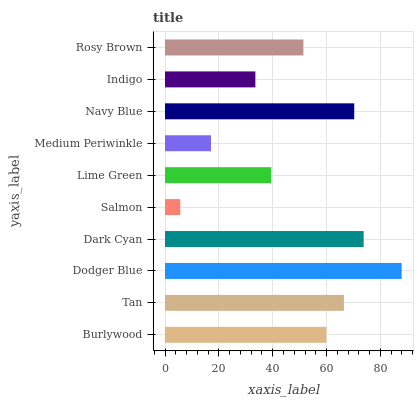Is Salmon the minimum?
Answer yes or no. Yes. Is Dodger Blue the maximum?
Answer yes or no. Yes. Is Tan the minimum?
Answer yes or no. No. Is Tan the maximum?
Answer yes or no. No. Is Tan greater than Burlywood?
Answer yes or no. Yes. Is Burlywood less than Tan?
Answer yes or no. Yes. Is Burlywood greater than Tan?
Answer yes or no. No. Is Tan less than Burlywood?
Answer yes or no. No. Is Burlywood the high median?
Answer yes or no. Yes. Is Rosy Brown the low median?
Answer yes or no. Yes. Is Dark Cyan the high median?
Answer yes or no. No. Is Lime Green the low median?
Answer yes or no. No. 